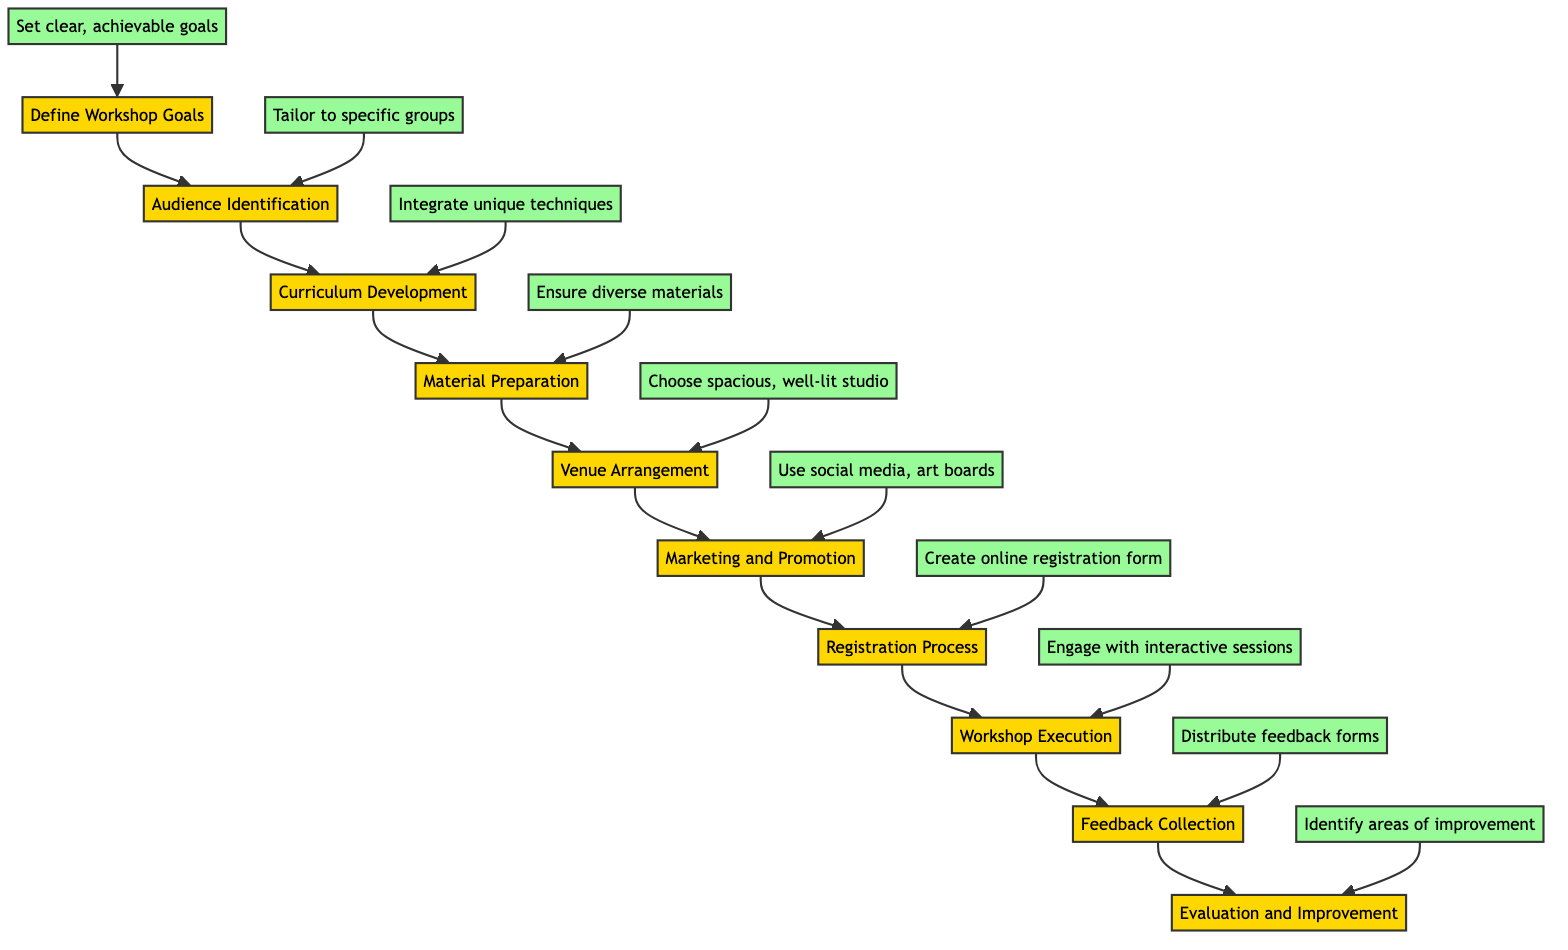What is the first step in the workshop organization process? The first step is indicated in the diagram as "Define Workshop Goals", which is connected at the top of the flowchart.
Answer: Define Workshop Goals How many total steps are there in the flowchart? By counting the nodes in the flowchart, there are a total of ten steps listed sequentially from start to finish.
Answer: 10 What comes after "Material Preparation"? The diagram shows that the next step following "Material Preparation" is "Venue Arrangement", as indicated by the arrow pointing down to that node.
Answer: Venue Arrangement What action is associated with "Audience Identification"? The flowchart links "Audience Identification" to the action "Tailor to specific groups" which defines what needs to be done regarding identifying the audience.
Answer: Tailor to specific groups What is the action that takes place during "Workshop Execution"? The action associated with "Workshop Execution" is to "Engage with interactive sessions", which describes how the workshop should be conducted.
Answer: Engage with interactive sessions Which step follows "Feedback Collection"? According to the flowchart, after "Feedback Collection" the next step is "Evaluation and Improvement", indicating the order of actions.
Answer: Evaluation and Improvement What is the last step in the workshop organization process? The final step in the flowchart, as shown at the bottom, is "Evaluation and Improvement", which concludes the process.
Answer: Evaluation and Improvement What step involves using social media for promotion? The diagram connects "Marketing and Promotion" to the action described as "Use social media, art boards", indicating how the workshop should be marketed.
Answer: Use social media, art boards How is the curriculum described in the diagram? The "Curriculum Development" step is associated with the action "Integrate unique techniques", which explains the nature of the curriculum being developed.
Answer: Integrate unique techniques What type of venue is suggested for the workshop? The flowchart specifies that the chosen venue should be a "spacious, well-lit studio", indicating the preferred characteristics of the space.
Answer: Spacious, well-lit studio 